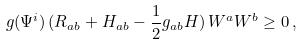<formula> <loc_0><loc_0><loc_500><loc_500>g ( \Psi ^ { i } ) \, ( R _ { a b } + H _ { a b } - \frac { 1 } { 2 } g _ { a b } H ) \, W ^ { a } W ^ { b } \geq 0 \, ,</formula> 